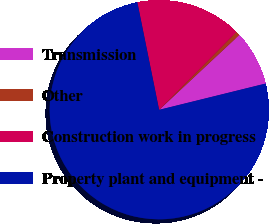Convert chart. <chart><loc_0><loc_0><loc_500><loc_500><pie_chart><fcel>Transmission<fcel>Other<fcel>Construction work in progress<fcel>Property plant and equipment -<nl><fcel>8.11%<fcel>0.6%<fcel>15.62%<fcel>75.68%<nl></chart> 